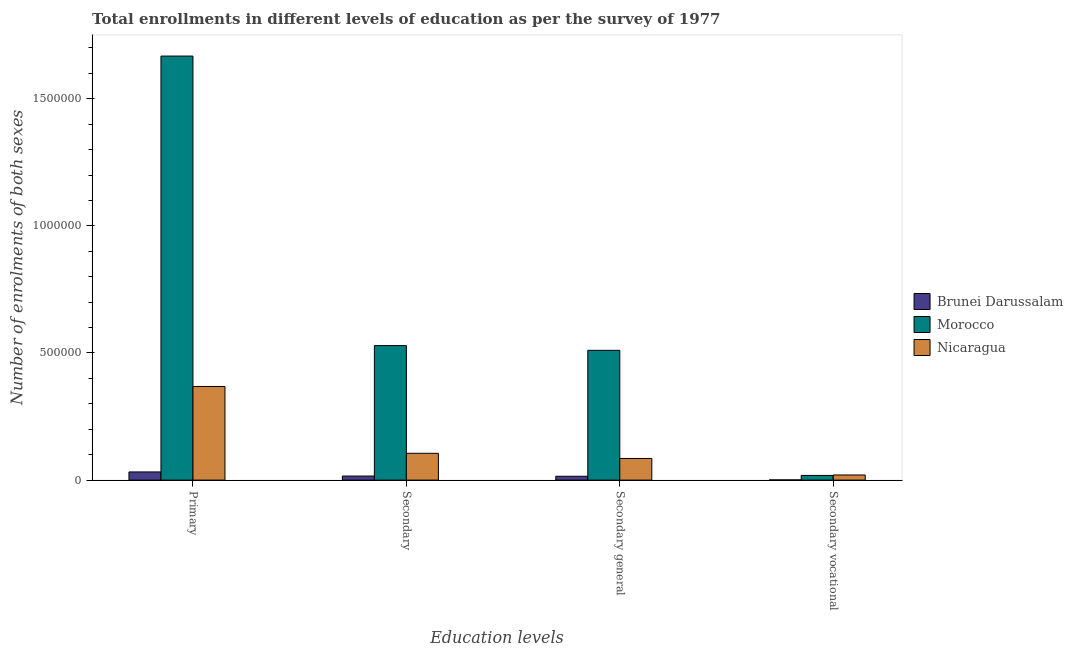How many different coloured bars are there?
Give a very brief answer. 3. Are the number of bars on each tick of the X-axis equal?
Your answer should be very brief. Yes. How many bars are there on the 3rd tick from the left?
Provide a short and direct response. 3. What is the label of the 2nd group of bars from the left?
Give a very brief answer. Secondary. What is the number of enrolments in secondary education in Morocco?
Provide a short and direct response. 5.29e+05. Across all countries, what is the maximum number of enrolments in primary education?
Ensure brevity in your answer.  1.67e+06. Across all countries, what is the minimum number of enrolments in secondary vocational education?
Give a very brief answer. 801. In which country was the number of enrolments in secondary vocational education maximum?
Your response must be concise. Nicaragua. In which country was the number of enrolments in secondary general education minimum?
Offer a terse response. Brunei Darussalam. What is the total number of enrolments in secondary general education in the graph?
Provide a short and direct response. 6.11e+05. What is the difference between the number of enrolments in primary education in Morocco and that in Brunei Darussalam?
Your answer should be very brief. 1.64e+06. What is the difference between the number of enrolments in secondary general education in Brunei Darussalam and the number of enrolments in secondary education in Morocco?
Keep it short and to the point. -5.14e+05. What is the average number of enrolments in primary education per country?
Offer a very short reply. 6.89e+05. What is the difference between the number of enrolments in secondary education and number of enrolments in secondary vocational education in Nicaragua?
Keep it short and to the point. 8.52e+04. What is the ratio of the number of enrolments in secondary general education in Nicaragua to that in Brunei Darussalam?
Provide a short and direct response. 5.6. Is the difference between the number of enrolments in primary education in Nicaragua and Brunei Darussalam greater than the difference between the number of enrolments in secondary general education in Nicaragua and Brunei Darussalam?
Your answer should be compact. Yes. What is the difference between the highest and the second highest number of enrolments in secondary education?
Provide a succinct answer. 4.24e+05. What is the difference between the highest and the lowest number of enrolments in secondary vocational education?
Your answer should be very brief. 1.94e+04. Is the sum of the number of enrolments in secondary education in Morocco and Nicaragua greater than the maximum number of enrolments in secondary vocational education across all countries?
Keep it short and to the point. Yes. What does the 2nd bar from the left in Secondary general represents?
Your answer should be very brief. Morocco. What does the 2nd bar from the right in Primary represents?
Make the answer very short. Morocco. Is it the case that in every country, the sum of the number of enrolments in primary education and number of enrolments in secondary education is greater than the number of enrolments in secondary general education?
Your answer should be compact. Yes. How many countries are there in the graph?
Your answer should be compact. 3. What is the difference between two consecutive major ticks on the Y-axis?
Provide a short and direct response. 5.00e+05. Does the graph contain any zero values?
Offer a terse response. No. Where does the legend appear in the graph?
Keep it short and to the point. Center right. How many legend labels are there?
Offer a terse response. 3. What is the title of the graph?
Ensure brevity in your answer.  Total enrollments in different levels of education as per the survey of 1977. What is the label or title of the X-axis?
Offer a very short reply. Education levels. What is the label or title of the Y-axis?
Keep it short and to the point. Number of enrolments of both sexes. What is the Number of enrolments of both sexes in Brunei Darussalam in Primary?
Your response must be concise. 3.22e+04. What is the Number of enrolments of both sexes of Morocco in Primary?
Give a very brief answer. 1.67e+06. What is the Number of enrolments of both sexes in Nicaragua in Primary?
Provide a short and direct response. 3.68e+05. What is the Number of enrolments of both sexes of Brunei Darussalam in Secondary?
Ensure brevity in your answer.  1.60e+04. What is the Number of enrolments of both sexes of Morocco in Secondary?
Offer a very short reply. 5.29e+05. What is the Number of enrolments of both sexes in Nicaragua in Secondary?
Your response must be concise. 1.05e+05. What is the Number of enrolments of both sexes of Brunei Darussalam in Secondary general?
Your answer should be very brief. 1.52e+04. What is the Number of enrolments of both sexes of Morocco in Secondary general?
Ensure brevity in your answer.  5.11e+05. What is the Number of enrolments of both sexes in Nicaragua in Secondary general?
Make the answer very short. 8.52e+04. What is the Number of enrolments of both sexes of Brunei Darussalam in Secondary vocational?
Your response must be concise. 801. What is the Number of enrolments of both sexes of Morocco in Secondary vocational?
Provide a short and direct response. 1.85e+04. What is the Number of enrolments of both sexes of Nicaragua in Secondary vocational?
Your answer should be very brief. 2.02e+04. Across all Education levels, what is the maximum Number of enrolments of both sexes of Brunei Darussalam?
Your answer should be very brief. 3.22e+04. Across all Education levels, what is the maximum Number of enrolments of both sexes in Morocco?
Ensure brevity in your answer.  1.67e+06. Across all Education levels, what is the maximum Number of enrolments of both sexes in Nicaragua?
Your answer should be very brief. 3.68e+05. Across all Education levels, what is the minimum Number of enrolments of both sexes of Brunei Darussalam?
Give a very brief answer. 801. Across all Education levels, what is the minimum Number of enrolments of both sexes in Morocco?
Keep it short and to the point. 1.85e+04. Across all Education levels, what is the minimum Number of enrolments of both sexes of Nicaragua?
Make the answer very short. 2.02e+04. What is the total Number of enrolments of both sexes in Brunei Darussalam in the graph?
Provide a short and direct response. 6.42e+04. What is the total Number of enrolments of both sexes in Morocco in the graph?
Your answer should be compact. 2.73e+06. What is the total Number of enrolments of both sexes of Nicaragua in the graph?
Provide a short and direct response. 5.79e+05. What is the difference between the Number of enrolments of both sexes in Brunei Darussalam in Primary and that in Secondary?
Provide a succinct answer. 1.62e+04. What is the difference between the Number of enrolments of both sexes of Morocco in Primary and that in Secondary?
Your answer should be very brief. 1.14e+06. What is the difference between the Number of enrolments of both sexes in Nicaragua in Primary and that in Secondary?
Make the answer very short. 2.63e+05. What is the difference between the Number of enrolments of both sexes of Brunei Darussalam in Primary and that in Secondary general?
Make the answer very short. 1.70e+04. What is the difference between the Number of enrolments of both sexes of Morocco in Primary and that in Secondary general?
Make the answer very short. 1.16e+06. What is the difference between the Number of enrolments of both sexes in Nicaragua in Primary and that in Secondary general?
Give a very brief answer. 2.83e+05. What is the difference between the Number of enrolments of both sexes in Brunei Darussalam in Primary and that in Secondary vocational?
Give a very brief answer. 3.14e+04. What is the difference between the Number of enrolments of both sexes of Morocco in Primary and that in Secondary vocational?
Make the answer very short. 1.65e+06. What is the difference between the Number of enrolments of both sexes in Nicaragua in Primary and that in Secondary vocational?
Your answer should be very brief. 3.48e+05. What is the difference between the Number of enrolments of both sexes of Brunei Darussalam in Secondary and that in Secondary general?
Your answer should be very brief. 801. What is the difference between the Number of enrolments of both sexes in Morocco in Secondary and that in Secondary general?
Give a very brief answer. 1.85e+04. What is the difference between the Number of enrolments of both sexes of Nicaragua in Secondary and that in Secondary general?
Your response must be concise. 2.02e+04. What is the difference between the Number of enrolments of both sexes in Brunei Darussalam in Secondary and that in Secondary vocational?
Your response must be concise. 1.52e+04. What is the difference between the Number of enrolments of both sexes in Morocco in Secondary and that in Secondary vocational?
Provide a short and direct response. 5.11e+05. What is the difference between the Number of enrolments of both sexes in Nicaragua in Secondary and that in Secondary vocational?
Ensure brevity in your answer.  8.52e+04. What is the difference between the Number of enrolments of both sexes in Brunei Darussalam in Secondary general and that in Secondary vocational?
Offer a terse response. 1.44e+04. What is the difference between the Number of enrolments of both sexes of Morocco in Secondary general and that in Secondary vocational?
Provide a succinct answer. 4.92e+05. What is the difference between the Number of enrolments of both sexes of Nicaragua in Secondary general and that in Secondary vocational?
Offer a very short reply. 6.50e+04. What is the difference between the Number of enrolments of both sexes in Brunei Darussalam in Primary and the Number of enrolments of both sexes in Morocco in Secondary?
Your response must be concise. -4.97e+05. What is the difference between the Number of enrolments of both sexes in Brunei Darussalam in Primary and the Number of enrolments of both sexes in Nicaragua in Secondary?
Your response must be concise. -7.32e+04. What is the difference between the Number of enrolments of both sexes in Morocco in Primary and the Number of enrolments of both sexes in Nicaragua in Secondary?
Your answer should be compact. 1.56e+06. What is the difference between the Number of enrolments of both sexes of Brunei Darussalam in Primary and the Number of enrolments of both sexes of Morocco in Secondary general?
Keep it short and to the point. -4.78e+05. What is the difference between the Number of enrolments of both sexes in Brunei Darussalam in Primary and the Number of enrolments of both sexes in Nicaragua in Secondary general?
Ensure brevity in your answer.  -5.30e+04. What is the difference between the Number of enrolments of both sexes of Morocco in Primary and the Number of enrolments of both sexes of Nicaragua in Secondary general?
Your response must be concise. 1.58e+06. What is the difference between the Number of enrolments of both sexes in Brunei Darussalam in Primary and the Number of enrolments of both sexes in Morocco in Secondary vocational?
Offer a terse response. 1.37e+04. What is the difference between the Number of enrolments of both sexes of Brunei Darussalam in Primary and the Number of enrolments of both sexes of Nicaragua in Secondary vocational?
Provide a succinct answer. 1.20e+04. What is the difference between the Number of enrolments of both sexes in Morocco in Primary and the Number of enrolments of both sexes in Nicaragua in Secondary vocational?
Your response must be concise. 1.65e+06. What is the difference between the Number of enrolments of both sexes of Brunei Darussalam in Secondary and the Number of enrolments of both sexes of Morocco in Secondary general?
Your response must be concise. -4.95e+05. What is the difference between the Number of enrolments of both sexes in Brunei Darussalam in Secondary and the Number of enrolments of both sexes in Nicaragua in Secondary general?
Make the answer very short. -6.92e+04. What is the difference between the Number of enrolments of both sexes in Morocco in Secondary and the Number of enrolments of both sexes in Nicaragua in Secondary general?
Ensure brevity in your answer.  4.44e+05. What is the difference between the Number of enrolments of both sexes of Brunei Darussalam in Secondary and the Number of enrolments of both sexes of Morocco in Secondary vocational?
Your answer should be very brief. -2513. What is the difference between the Number of enrolments of both sexes of Brunei Darussalam in Secondary and the Number of enrolments of both sexes of Nicaragua in Secondary vocational?
Your answer should be compact. -4232. What is the difference between the Number of enrolments of both sexes in Morocco in Secondary and the Number of enrolments of both sexes in Nicaragua in Secondary vocational?
Offer a very short reply. 5.09e+05. What is the difference between the Number of enrolments of both sexes of Brunei Darussalam in Secondary general and the Number of enrolments of both sexes of Morocco in Secondary vocational?
Make the answer very short. -3314. What is the difference between the Number of enrolments of both sexes of Brunei Darussalam in Secondary general and the Number of enrolments of both sexes of Nicaragua in Secondary vocational?
Your response must be concise. -5033. What is the difference between the Number of enrolments of both sexes of Morocco in Secondary general and the Number of enrolments of both sexes of Nicaragua in Secondary vocational?
Provide a short and direct response. 4.90e+05. What is the average Number of enrolments of both sexes in Brunei Darussalam per Education levels?
Provide a short and direct response. 1.60e+04. What is the average Number of enrolments of both sexes in Morocco per Education levels?
Your response must be concise. 6.81e+05. What is the average Number of enrolments of both sexes in Nicaragua per Education levels?
Give a very brief answer. 1.45e+05. What is the difference between the Number of enrolments of both sexes in Brunei Darussalam and Number of enrolments of both sexes in Morocco in Primary?
Your answer should be compact. -1.64e+06. What is the difference between the Number of enrolments of both sexes of Brunei Darussalam and Number of enrolments of both sexes of Nicaragua in Primary?
Your response must be concise. -3.36e+05. What is the difference between the Number of enrolments of both sexes in Morocco and Number of enrolments of both sexes in Nicaragua in Primary?
Keep it short and to the point. 1.30e+06. What is the difference between the Number of enrolments of both sexes of Brunei Darussalam and Number of enrolments of both sexes of Morocco in Secondary?
Provide a short and direct response. -5.13e+05. What is the difference between the Number of enrolments of both sexes of Brunei Darussalam and Number of enrolments of both sexes of Nicaragua in Secondary?
Keep it short and to the point. -8.94e+04. What is the difference between the Number of enrolments of both sexes in Morocco and Number of enrolments of both sexes in Nicaragua in Secondary?
Your answer should be very brief. 4.24e+05. What is the difference between the Number of enrolments of both sexes of Brunei Darussalam and Number of enrolments of both sexes of Morocco in Secondary general?
Offer a terse response. -4.95e+05. What is the difference between the Number of enrolments of both sexes of Brunei Darussalam and Number of enrolments of both sexes of Nicaragua in Secondary general?
Make the answer very short. -7.00e+04. What is the difference between the Number of enrolments of both sexes of Morocco and Number of enrolments of both sexes of Nicaragua in Secondary general?
Make the answer very short. 4.25e+05. What is the difference between the Number of enrolments of both sexes of Brunei Darussalam and Number of enrolments of both sexes of Morocco in Secondary vocational?
Offer a terse response. -1.77e+04. What is the difference between the Number of enrolments of both sexes in Brunei Darussalam and Number of enrolments of both sexes in Nicaragua in Secondary vocational?
Provide a succinct answer. -1.94e+04. What is the difference between the Number of enrolments of both sexes in Morocco and Number of enrolments of both sexes in Nicaragua in Secondary vocational?
Provide a succinct answer. -1719. What is the ratio of the Number of enrolments of both sexes of Brunei Darussalam in Primary to that in Secondary?
Ensure brevity in your answer.  2.01. What is the ratio of the Number of enrolments of both sexes in Morocco in Primary to that in Secondary?
Provide a succinct answer. 3.15. What is the ratio of the Number of enrolments of both sexes of Nicaragua in Primary to that in Secondary?
Ensure brevity in your answer.  3.49. What is the ratio of the Number of enrolments of both sexes in Brunei Darussalam in Primary to that in Secondary general?
Give a very brief answer. 2.12. What is the ratio of the Number of enrolments of both sexes of Morocco in Primary to that in Secondary general?
Give a very brief answer. 3.27. What is the ratio of the Number of enrolments of both sexes of Nicaragua in Primary to that in Secondary general?
Your answer should be compact. 4.32. What is the ratio of the Number of enrolments of both sexes in Brunei Darussalam in Primary to that in Secondary vocational?
Your answer should be compact. 40.18. What is the ratio of the Number of enrolments of both sexes in Morocco in Primary to that in Secondary vocational?
Offer a very short reply. 90.06. What is the ratio of the Number of enrolments of both sexes of Nicaragua in Primary to that in Secondary vocational?
Make the answer very short. 18.2. What is the ratio of the Number of enrolments of both sexes of Brunei Darussalam in Secondary to that in Secondary general?
Provide a short and direct response. 1.05. What is the ratio of the Number of enrolments of both sexes of Morocco in Secondary to that in Secondary general?
Give a very brief answer. 1.04. What is the ratio of the Number of enrolments of both sexes in Nicaragua in Secondary to that in Secondary general?
Keep it short and to the point. 1.24. What is the ratio of the Number of enrolments of both sexes of Brunei Darussalam in Secondary to that in Secondary vocational?
Your response must be concise. 19.98. What is the ratio of the Number of enrolments of both sexes of Morocco in Secondary to that in Secondary vocational?
Offer a very short reply. 28.57. What is the ratio of the Number of enrolments of both sexes in Nicaragua in Secondary to that in Secondary vocational?
Offer a terse response. 5.21. What is the ratio of the Number of enrolments of both sexes of Brunei Darussalam in Secondary general to that in Secondary vocational?
Keep it short and to the point. 18.98. What is the ratio of the Number of enrolments of both sexes of Morocco in Secondary general to that in Secondary vocational?
Provide a succinct answer. 27.57. What is the ratio of the Number of enrolments of both sexes of Nicaragua in Secondary general to that in Secondary vocational?
Ensure brevity in your answer.  4.21. What is the difference between the highest and the second highest Number of enrolments of both sexes of Brunei Darussalam?
Offer a terse response. 1.62e+04. What is the difference between the highest and the second highest Number of enrolments of both sexes of Morocco?
Give a very brief answer. 1.14e+06. What is the difference between the highest and the second highest Number of enrolments of both sexes in Nicaragua?
Offer a very short reply. 2.63e+05. What is the difference between the highest and the lowest Number of enrolments of both sexes of Brunei Darussalam?
Offer a very short reply. 3.14e+04. What is the difference between the highest and the lowest Number of enrolments of both sexes in Morocco?
Your response must be concise. 1.65e+06. What is the difference between the highest and the lowest Number of enrolments of both sexes of Nicaragua?
Your response must be concise. 3.48e+05. 